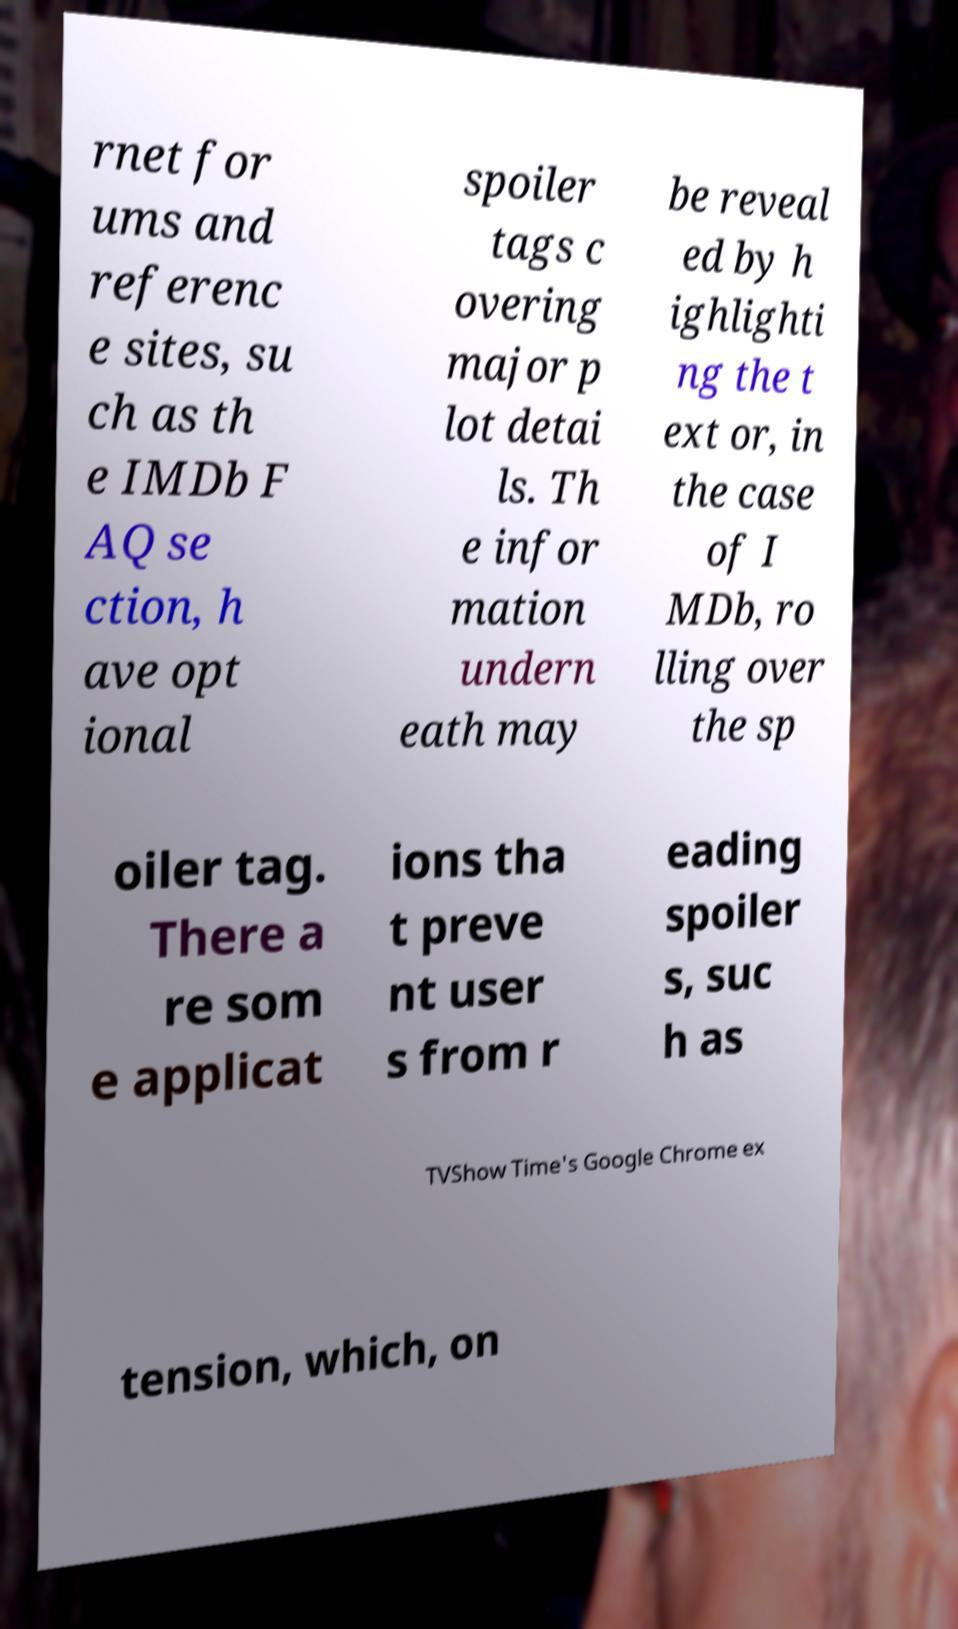For documentation purposes, I need the text within this image transcribed. Could you provide that? rnet for ums and referenc e sites, su ch as th e IMDb F AQ se ction, h ave opt ional spoiler tags c overing major p lot detai ls. Th e infor mation undern eath may be reveal ed by h ighlighti ng the t ext or, in the case of I MDb, ro lling over the sp oiler tag. There a re som e applicat ions tha t preve nt user s from r eading spoiler s, suc h as TVShow Time's Google Chrome ex tension, which, on 